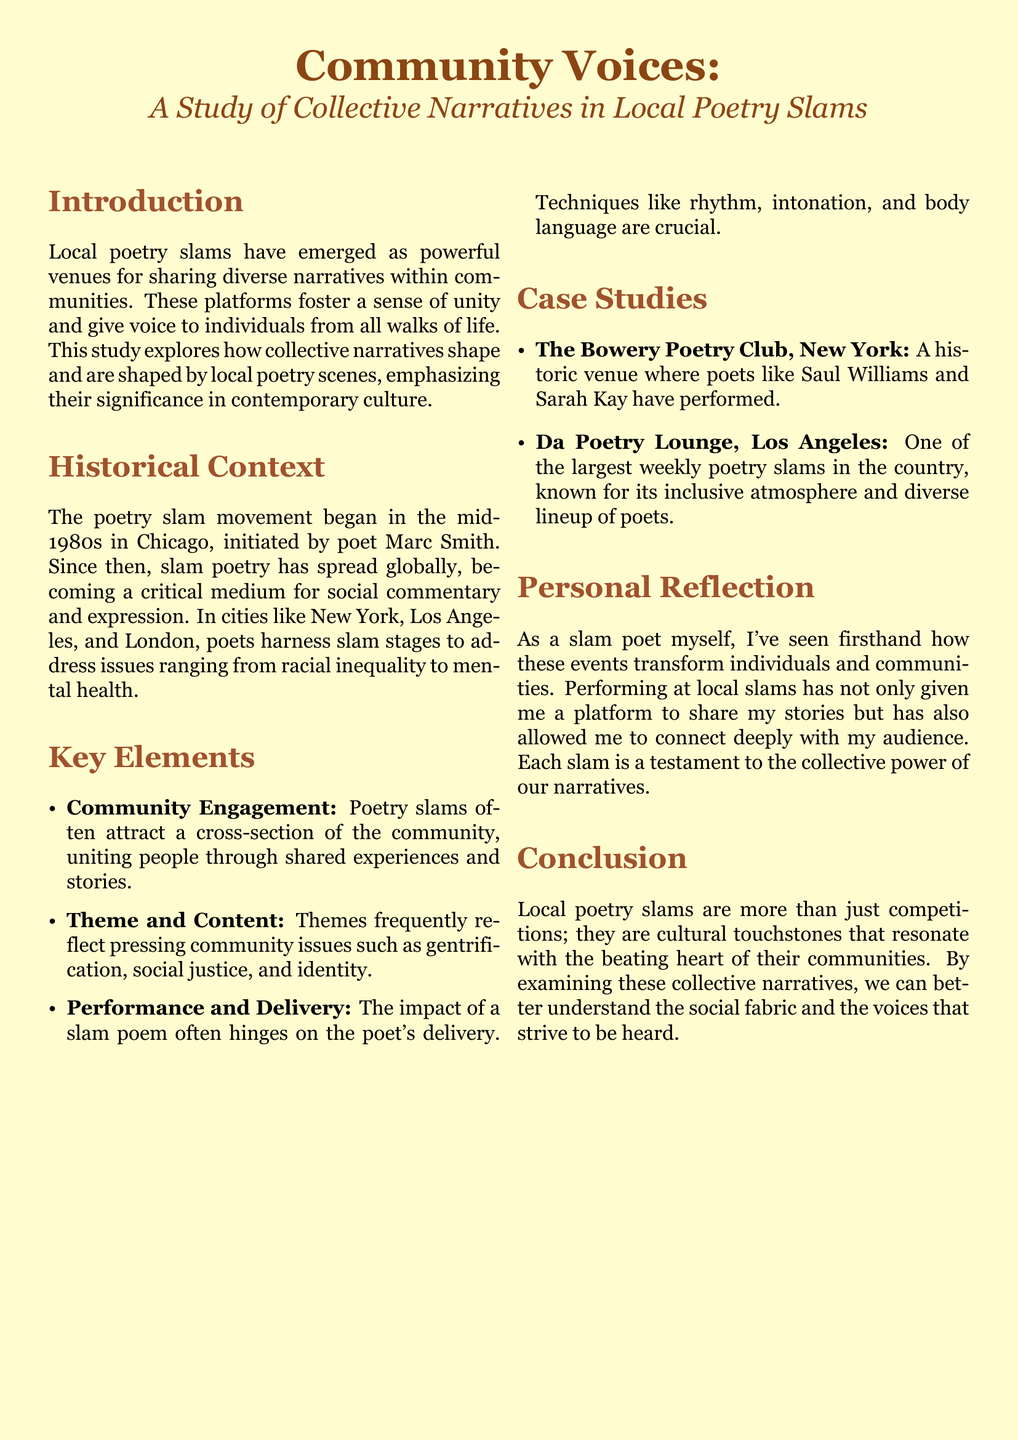What is the main focus of the study? The study explores how collective narratives shape and are shaped by local poetry scenes.
Answer: collective narratives Who initiated the poetry slam movement? The document states that the poetry slam movement was initiated by poet Marc Smith.
Answer: Marc Smith Which two cities are mentioned as critical locations for poetry slams? The document highlights Chicago, New York, and Los Angeles, but two specific cities can be identified from the context.
Answer: New York, Los Angeles What is a key element that impacts the effectiveness of a slam poem? The document emphasizes that techniques like rhythm, intonation, and body language are crucial for the impact of a slam poem.
Answer: delivery What is one thematic issue frequently addressed in poetry slams? The document mentions that slams address themes such as gentrification, social justice, and identity.
Answer: social justice How has the author personally experienced local slams? The author shares that performing at local slams has allowed for deep connections with the audience and a platform to share stories.
Answer: connecting with the audience What cultural role do local poetry slams play according to the conclusion? The conclusion states that local poetry slams are more than just competitions; they are cultural touchstones.
Answer: cultural touchstones Name one historic venue for poetry slams mentioned. The document lists The Bowery Poetry Club as a historic venue for poetry slams.
Answer: The Bowery Poetry Club 